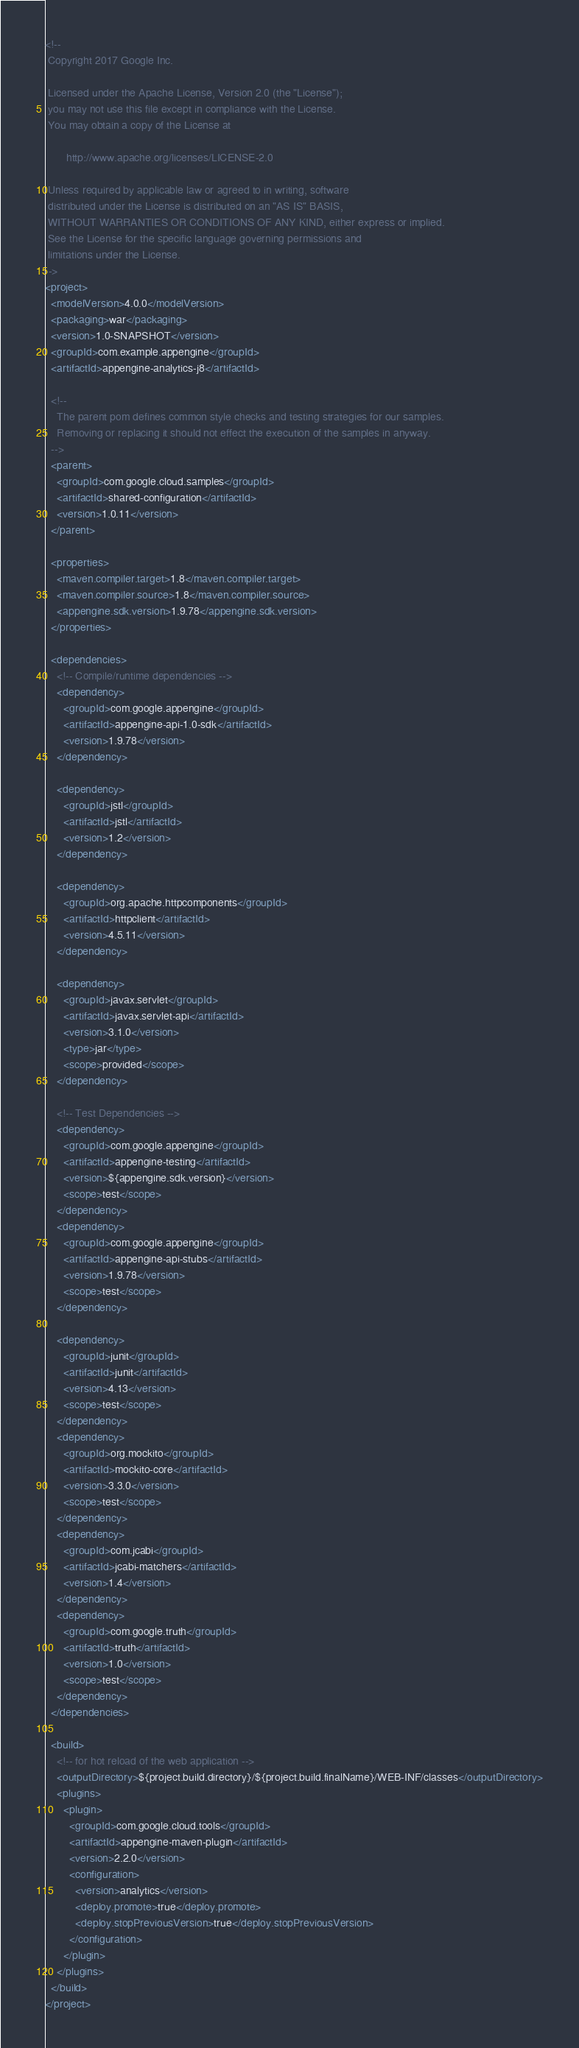<code> <loc_0><loc_0><loc_500><loc_500><_XML_><!--
 Copyright 2017 Google Inc.

 Licensed under the Apache License, Version 2.0 (the "License");
 you may not use this file except in compliance with the License.
 You may obtain a copy of the License at

       http://www.apache.org/licenses/LICENSE-2.0

 Unless required by applicable law or agreed to in writing, software
 distributed under the License is distributed on an "AS IS" BASIS,
 WITHOUT WARRANTIES OR CONDITIONS OF ANY KIND, either express or implied.
 See the License for the specific language governing permissions and
 limitations under the License.
-->
<project>
  <modelVersion>4.0.0</modelVersion>
  <packaging>war</packaging>
  <version>1.0-SNAPSHOT</version>
  <groupId>com.example.appengine</groupId>
  <artifactId>appengine-analytics-j8</artifactId>

  <!--
    The parent pom defines common style checks and testing strategies for our samples.
    Removing or replacing it should not effect the execution of the samples in anyway.
  -->
  <parent>
    <groupId>com.google.cloud.samples</groupId>
    <artifactId>shared-configuration</artifactId>
    <version>1.0.11</version>
  </parent>

  <properties>
    <maven.compiler.target>1.8</maven.compiler.target>
    <maven.compiler.source>1.8</maven.compiler.source>
    <appengine.sdk.version>1.9.78</appengine.sdk.version>
  </properties>

  <dependencies>
    <!-- Compile/runtime dependencies -->
    <dependency>
      <groupId>com.google.appengine</groupId>
      <artifactId>appengine-api-1.0-sdk</artifactId>
      <version>1.9.78</version>
    </dependency>

    <dependency>
      <groupId>jstl</groupId>
      <artifactId>jstl</artifactId>
      <version>1.2</version>
    </dependency>

    <dependency>
      <groupId>org.apache.httpcomponents</groupId>
      <artifactId>httpclient</artifactId>
      <version>4.5.11</version>
    </dependency>

    <dependency>
      <groupId>javax.servlet</groupId>
      <artifactId>javax.servlet-api</artifactId>
      <version>3.1.0</version>
      <type>jar</type>
      <scope>provided</scope>
    </dependency>

    <!-- Test Dependencies -->
    <dependency>
      <groupId>com.google.appengine</groupId>
      <artifactId>appengine-testing</artifactId>
      <version>${appengine.sdk.version}</version>
      <scope>test</scope>
    </dependency>
    <dependency>
      <groupId>com.google.appengine</groupId>
      <artifactId>appengine-api-stubs</artifactId>
      <version>1.9.78</version>
      <scope>test</scope>
    </dependency>

    <dependency>
      <groupId>junit</groupId>
      <artifactId>junit</artifactId>
      <version>4.13</version>
      <scope>test</scope>
    </dependency>
    <dependency>
      <groupId>org.mockito</groupId>
      <artifactId>mockito-core</artifactId>
      <version>3.3.0</version>
      <scope>test</scope>
    </dependency>
    <dependency>
      <groupId>com.jcabi</groupId>
      <artifactId>jcabi-matchers</artifactId>
      <version>1.4</version>
    </dependency>
    <dependency>
      <groupId>com.google.truth</groupId>
      <artifactId>truth</artifactId>
      <version>1.0</version>
      <scope>test</scope>
    </dependency>
  </dependencies>

  <build>
    <!-- for hot reload of the web application -->
    <outputDirectory>${project.build.directory}/${project.build.finalName}/WEB-INF/classes</outputDirectory>
    <plugins>
      <plugin>
        <groupId>com.google.cloud.tools</groupId>
        <artifactId>appengine-maven-plugin</artifactId>
        <version>2.2.0</version>
        <configuration>
          <version>analytics</version>
          <deploy.promote>true</deploy.promote>
          <deploy.stopPreviousVersion>true</deploy.stopPreviousVersion>
        </configuration>
      </plugin>
    </plugins>
  </build>
</project>
</code> 